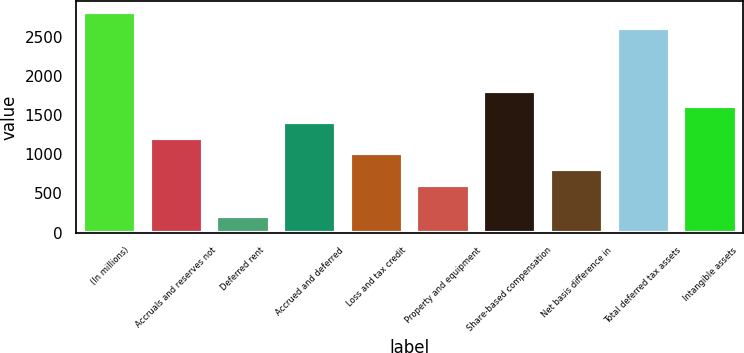Convert chart. <chart><loc_0><loc_0><loc_500><loc_500><bar_chart><fcel>(In millions)<fcel>Accruals and reserves not<fcel>Deferred rent<fcel>Accrued and deferred<fcel>Loss and tax credit<fcel>Property and equipment<fcel>Share-based compensation<fcel>Net basis difference in<fcel>Total deferred tax assets<fcel>Intangible assets<nl><fcel>2812.8<fcel>1211.2<fcel>210.2<fcel>1411.4<fcel>1011<fcel>610.6<fcel>1811.8<fcel>810.8<fcel>2612.6<fcel>1611.6<nl></chart> 